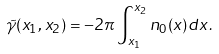Convert formula to latex. <formula><loc_0><loc_0><loc_500><loc_500>\tilde { \gamma } ( x _ { 1 } , x _ { 2 } ) = - 2 \pi \int _ { x _ { 1 } } ^ { x _ { 2 } } n _ { 0 } ( x ) d x \, .</formula> 